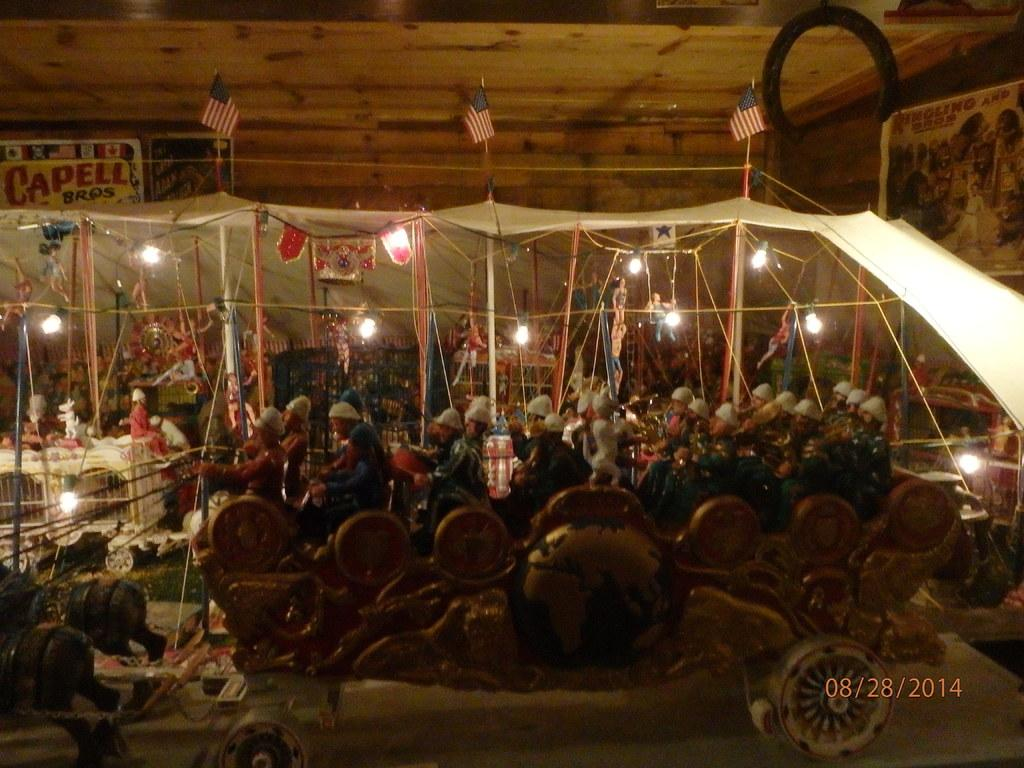What type of objects can be seen in the image? There are toys in the image. What else is visible in the image besides the toys? There are lights, a cloth, posters on the wall, and flags visible in the image. Can you describe the lights in the image? The lights are visible in the image, but their specific characteristics are not mentioned in the facts. What is on the wall in the image? There are posters on the wall in the image. What else can be seen in the image that is related to flags? There are flags in the image. What type of drum can be heard playing in the image? There is no drum present in the image, and therefore no sound can be heard. 